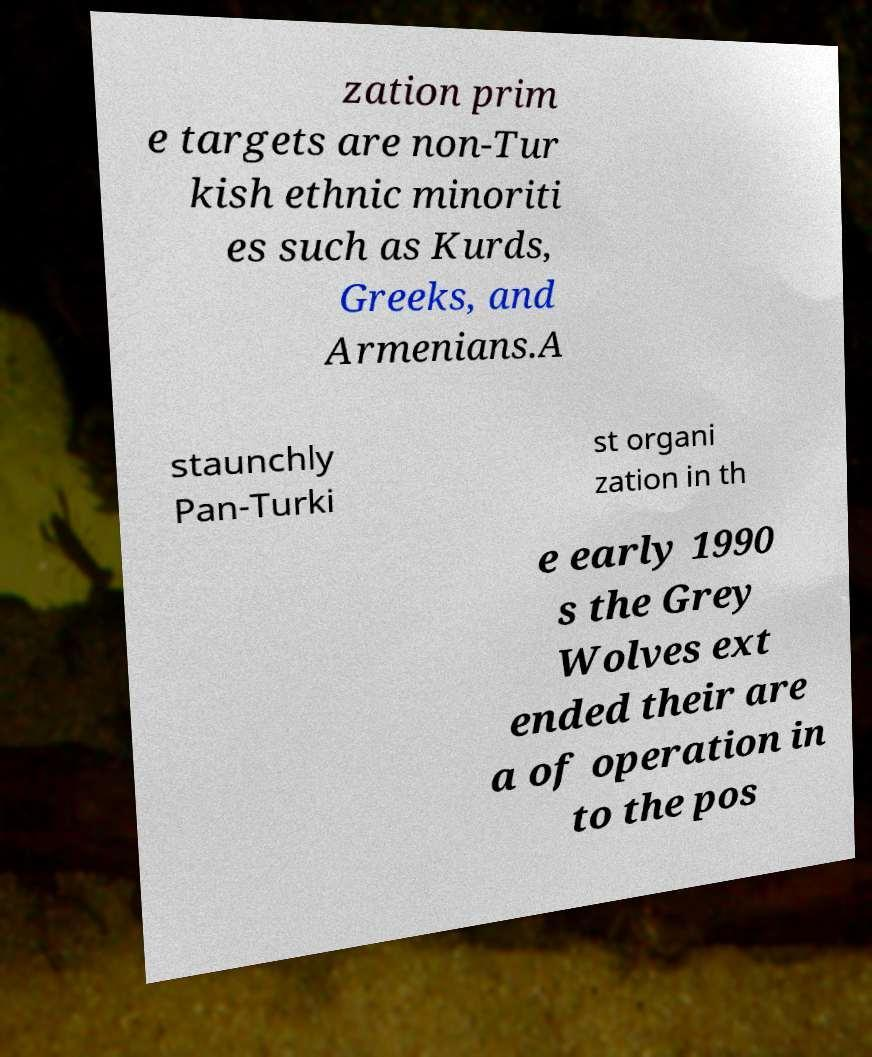Could you extract and type out the text from this image? zation prim e targets are non-Tur kish ethnic minoriti es such as Kurds, Greeks, and Armenians.A staunchly Pan-Turki st organi zation in th e early 1990 s the Grey Wolves ext ended their are a of operation in to the pos 